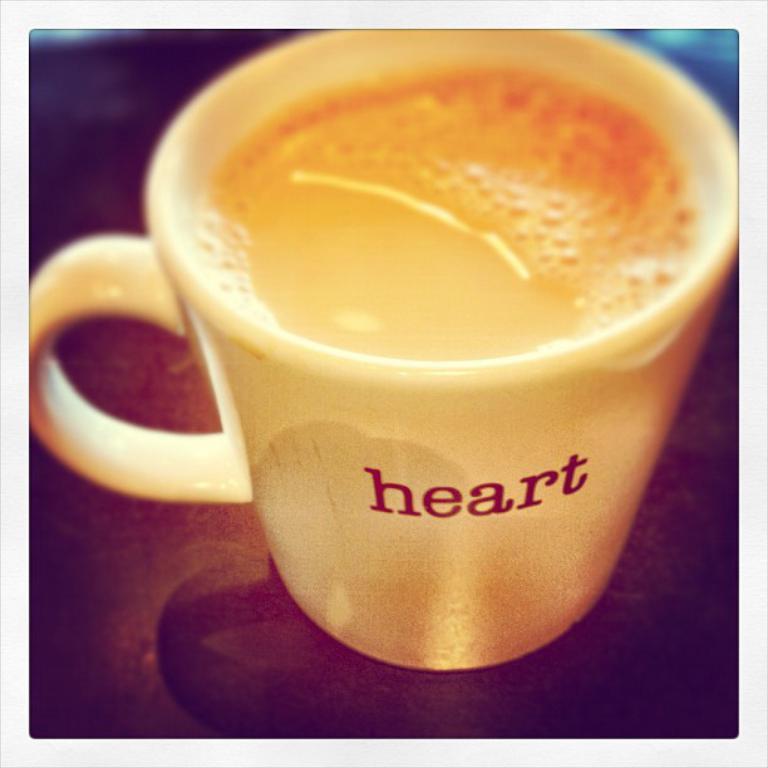In one or two sentences, can you explain what this image depicts? In this image I can see the cup on the brown color surface. There is a drink in the cup and I can see the name heart is written on the cup. 